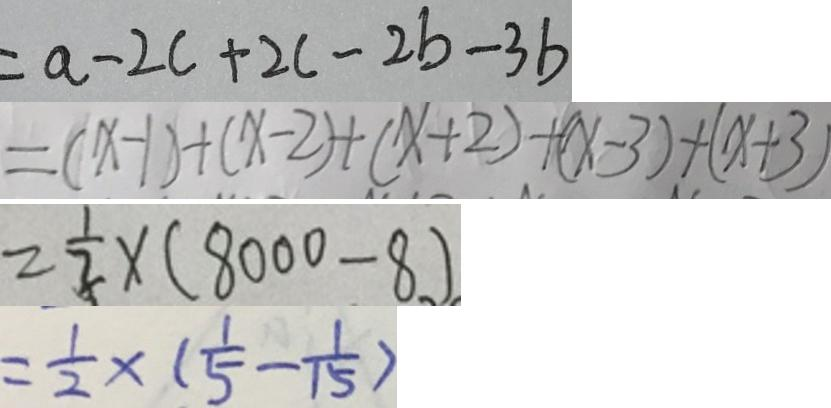Convert formula to latex. <formula><loc_0><loc_0><loc_500><loc_500>= a - 2 c + 2 c - 2 b - 3 b 
 = ( x - 1 ) + ( x - 2 ) + ( x + 2 ) + ( x - 3 ) + ( x + 3 ) 
 = \frac { 1 } { 2 } \times ( 8 0 0 0 - 8 ) 
 = \frac { 1 } { 2 } \times ( \frac { 1 } { 5 } - \frac { 1 } { 1 5 } )</formula> 